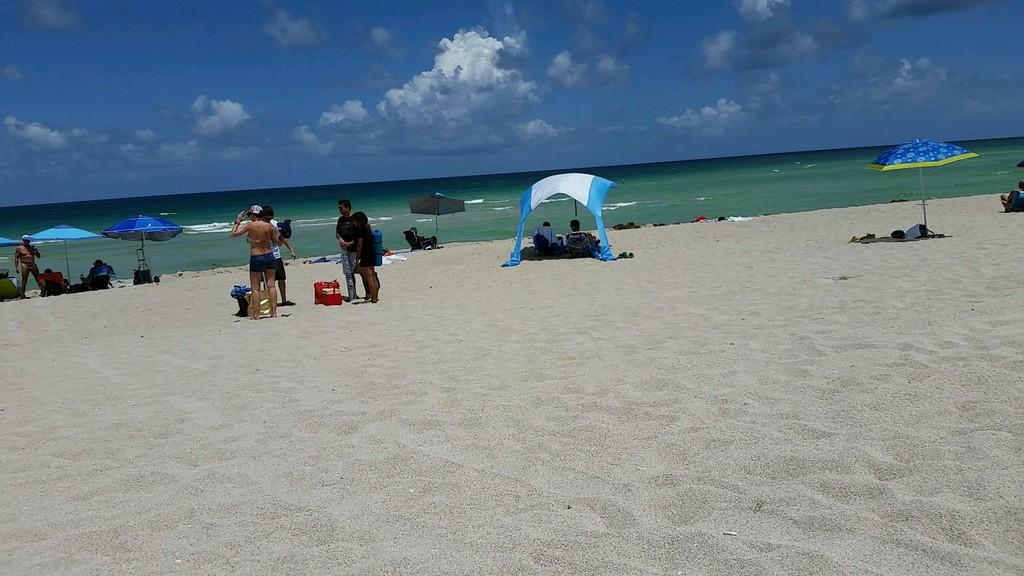Who is present in the image? There are people in the image. Where are the people located? The people are at the beach. What are some people using for shade in the image? Some people are under umbrellas. What can be seen in the distance behind the people? There is an ocean visible in the background of the image. What is visible in the sky in the background of the image? There are clouds in the sky in the background of the image. What type of foot race is taking place on the beach in the image? There is no foot race or competition present in the image; it simply shows people at the beach. 